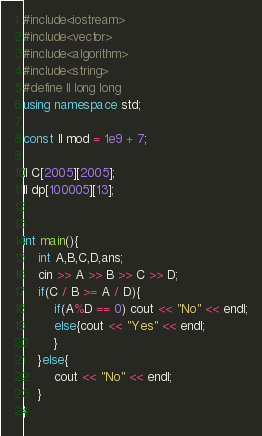<code> <loc_0><loc_0><loc_500><loc_500><_C++_>#include<iostream>
#include<vector>
#include<algorithm>
#include<string>
#define ll long long
using namespace std;

const ll mod = 1e9 + 7;

ll C[2005][2005];
ll dp[100005][13];


int main(){
    int A,B,C,D,ans;
    cin >> A >> B >> C >> D;
    if(C / B >= A / D){
        if(A%D == 0) cout << "No" << endl;
        else{cout << "Yes" << endl;
        }
    }else{
        cout << "No" << endl;
    }
}</code> 